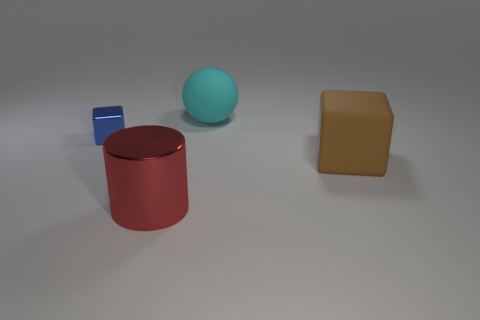Does the big shiny cylinder have the same color as the big matte object behind the brown block?
Offer a very short reply. No. How many objects are balls behind the brown rubber block or things right of the cylinder?
Your response must be concise. 2. There is a metal object that is in front of the metal thing left of the big cylinder; what is its shape?
Give a very brief answer. Cylinder. Are there any red things made of the same material as the blue block?
Provide a succinct answer. Yes. What color is the other metallic thing that is the same shape as the brown object?
Ensure brevity in your answer.  Blue. Is the number of big brown things that are to the left of the cyan matte sphere less than the number of brown things behind the large brown matte block?
Your response must be concise. No. What number of other things are there of the same shape as the big brown object?
Keep it short and to the point. 1. Is the number of big rubber cubes that are left of the blue cube less than the number of small brown metal cylinders?
Keep it short and to the point. No. There is a thing that is in front of the big brown matte cube; what material is it?
Ensure brevity in your answer.  Metal. How many other objects are there of the same size as the cyan thing?
Your answer should be very brief. 2. 